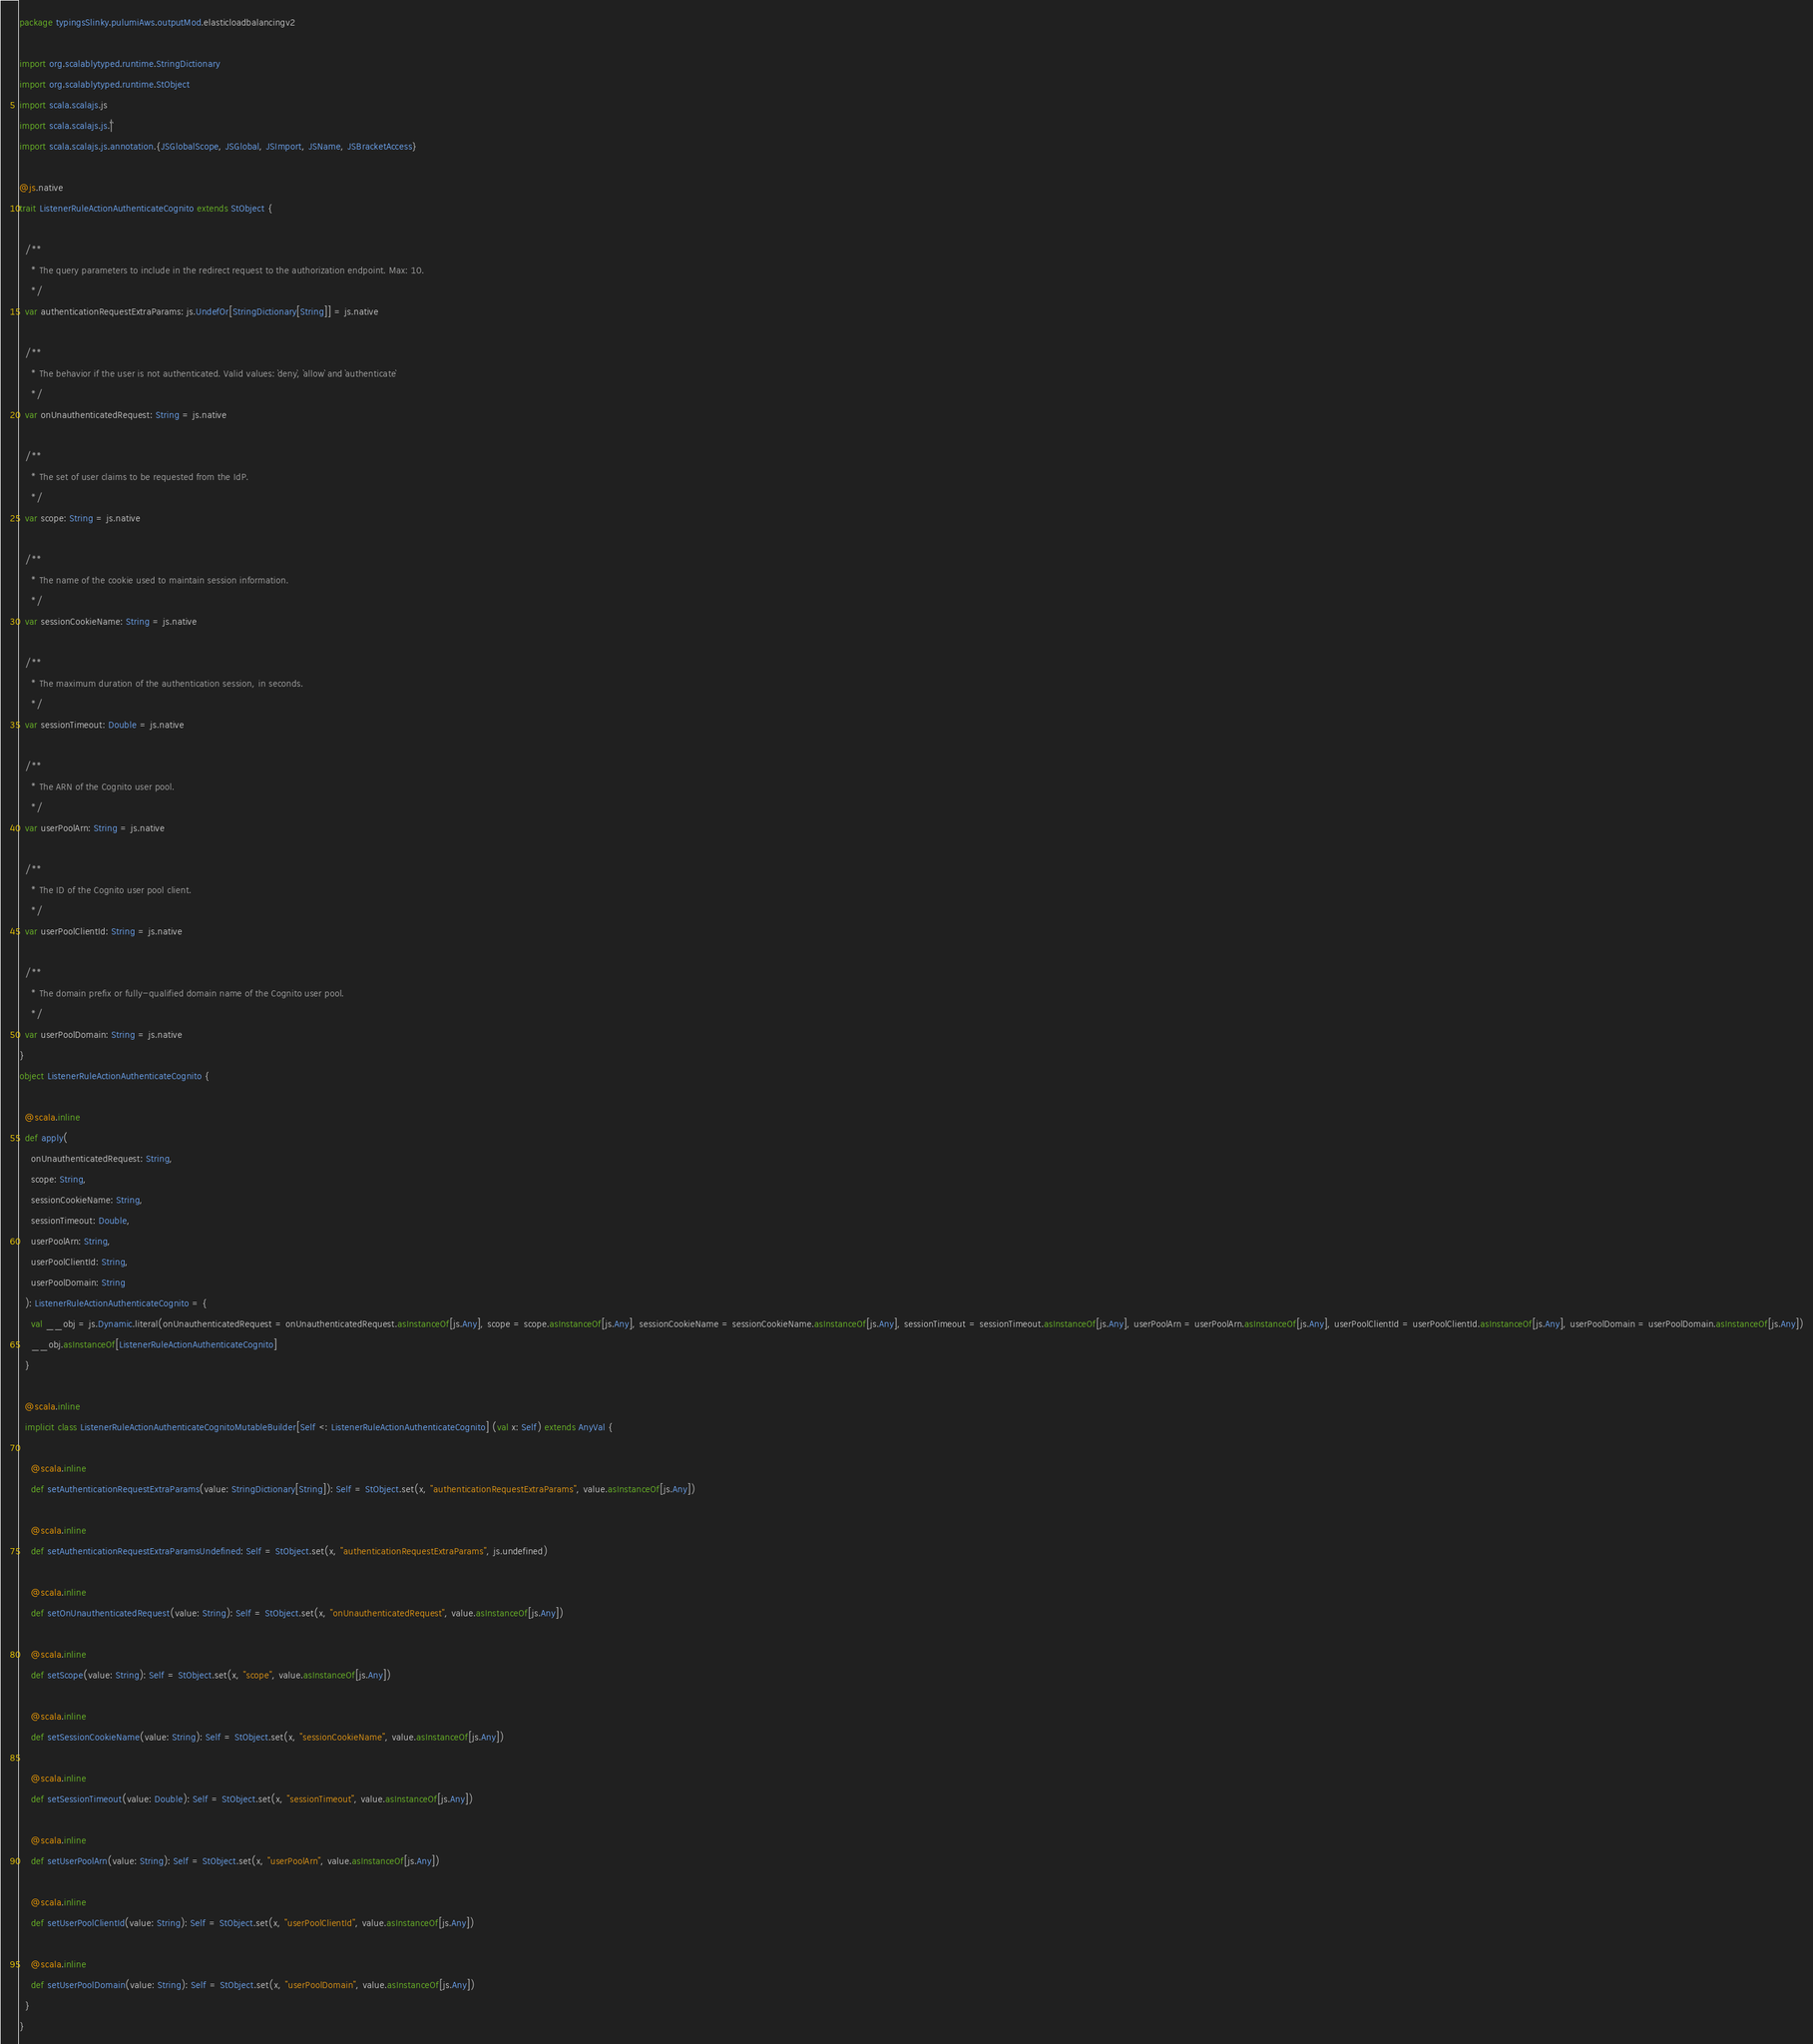Convert code to text. <code><loc_0><loc_0><loc_500><loc_500><_Scala_>package typingsSlinky.pulumiAws.outputMod.elasticloadbalancingv2

import org.scalablytyped.runtime.StringDictionary
import org.scalablytyped.runtime.StObject
import scala.scalajs.js
import scala.scalajs.js.`|`
import scala.scalajs.js.annotation.{JSGlobalScope, JSGlobal, JSImport, JSName, JSBracketAccess}

@js.native
trait ListenerRuleActionAuthenticateCognito extends StObject {
  
  /**
    * The query parameters to include in the redirect request to the authorization endpoint. Max: 10.
    */
  var authenticationRequestExtraParams: js.UndefOr[StringDictionary[String]] = js.native
  
  /**
    * The behavior if the user is not authenticated. Valid values: `deny`, `allow` and `authenticate`
    */
  var onUnauthenticatedRequest: String = js.native
  
  /**
    * The set of user claims to be requested from the IdP.
    */
  var scope: String = js.native
  
  /**
    * The name of the cookie used to maintain session information.
    */
  var sessionCookieName: String = js.native
  
  /**
    * The maximum duration of the authentication session, in seconds.
    */
  var sessionTimeout: Double = js.native
  
  /**
    * The ARN of the Cognito user pool.
    */
  var userPoolArn: String = js.native
  
  /**
    * The ID of the Cognito user pool client.
    */
  var userPoolClientId: String = js.native
  
  /**
    * The domain prefix or fully-qualified domain name of the Cognito user pool.
    */
  var userPoolDomain: String = js.native
}
object ListenerRuleActionAuthenticateCognito {
  
  @scala.inline
  def apply(
    onUnauthenticatedRequest: String,
    scope: String,
    sessionCookieName: String,
    sessionTimeout: Double,
    userPoolArn: String,
    userPoolClientId: String,
    userPoolDomain: String
  ): ListenerRuleActionAuthenticateCognito = {
    val __obj = js.Dynamic.literal(onUnauthenticatedRequest = onUnauthenticatedRequest.asInstanceOf[js.Any], scope = scope.asInstanceOf[js.Any], sessionCookieName = sessionCookieName.asInstanceOf[js.Any], sessionTimeout = sessionTimeout.asInstanceOf[js.Any], userPoolArn = userPoolArn.asInstanceOf[js.Any], userPoolClientId = userPoolClientId.asInstanceOf[js.Any], userPoolDomain = userPoolDomain.asInstanceOf[js.Any])
    __obj.asInstanceOf[ListenerRuleActionAuthenticateCognito]
  }
  
  @scala.inline
  implicit class ListenerRuleActionAuthenticateCognitoMutableBuilder[Self <: ListenerRuleActionAuthenticateCognito] (val x: Self) extends AnyVal {
    
    @scala.inline
    def setAuthenticationRequestExtraParams(value: StringDictionary[String]): Self = StObject.set(x, "authenticationRequestExtraParams", value.asInstanceOf[js.Any])
    
    @scala.inline
    def setAuthenticationRequestExtraParamsUndefined: Self = StObject.set(x, "authenticationRequestExtraParams", js.undefined)
    
    @scala.inline
    def setOnUnauthenticatedRequest(value: String): Self = StObject.set(x, "onUnauthenticatedRequest", value.asInstanceOf[js.Any])
    
    @scala.inline
    def setScope(value: String): Self = StObject.set(x, "scope", value.asInstanceOf[js.Any])
    
    @scala.inline
    def setSessionCookieName(value: String): Self = StObject.set(x, "sessionCookieName", value.asInstanceOf[js.Any])
    
    @scala.inline
    def setSessionTimeout(value: Double): Self = StObject.set(x, "sessionTimeout", value.asInstanceOf[js.Any])
    
    @scala.inline
    def setUserPoolArn(value: String): Self = StObject.set(x, "userPoolArn", value.asInstanceOf[js.Any])
    
    @scala.inline
    def setUserPoolClientId(value: String): Self = StObject.set(x, "userPoolClientId", value.asInstanceOf[js.Any])
    
    @scala.inline
    def setUserPoolDomain(value: String): Self = StObject.set(x, "userPoolDomain", value.asInstanceOf[js.Any])
  }
}
</code> 